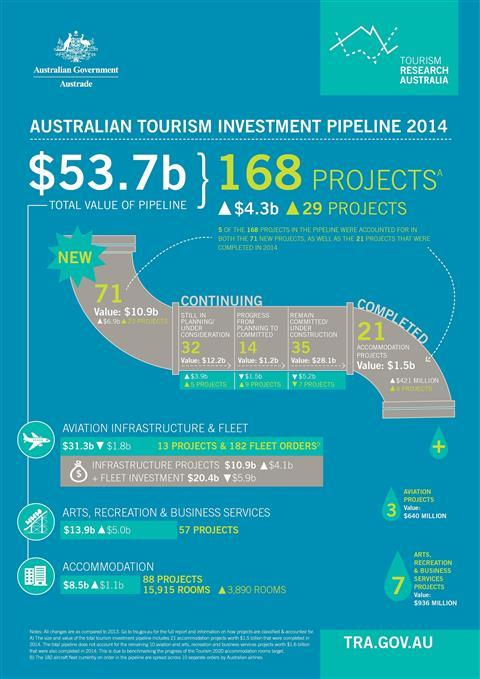Point out several critical features in this image. The value of projects in the pipeline is currently estimated to be $53.7 billion. Aviation projects are valued at $640 million. 